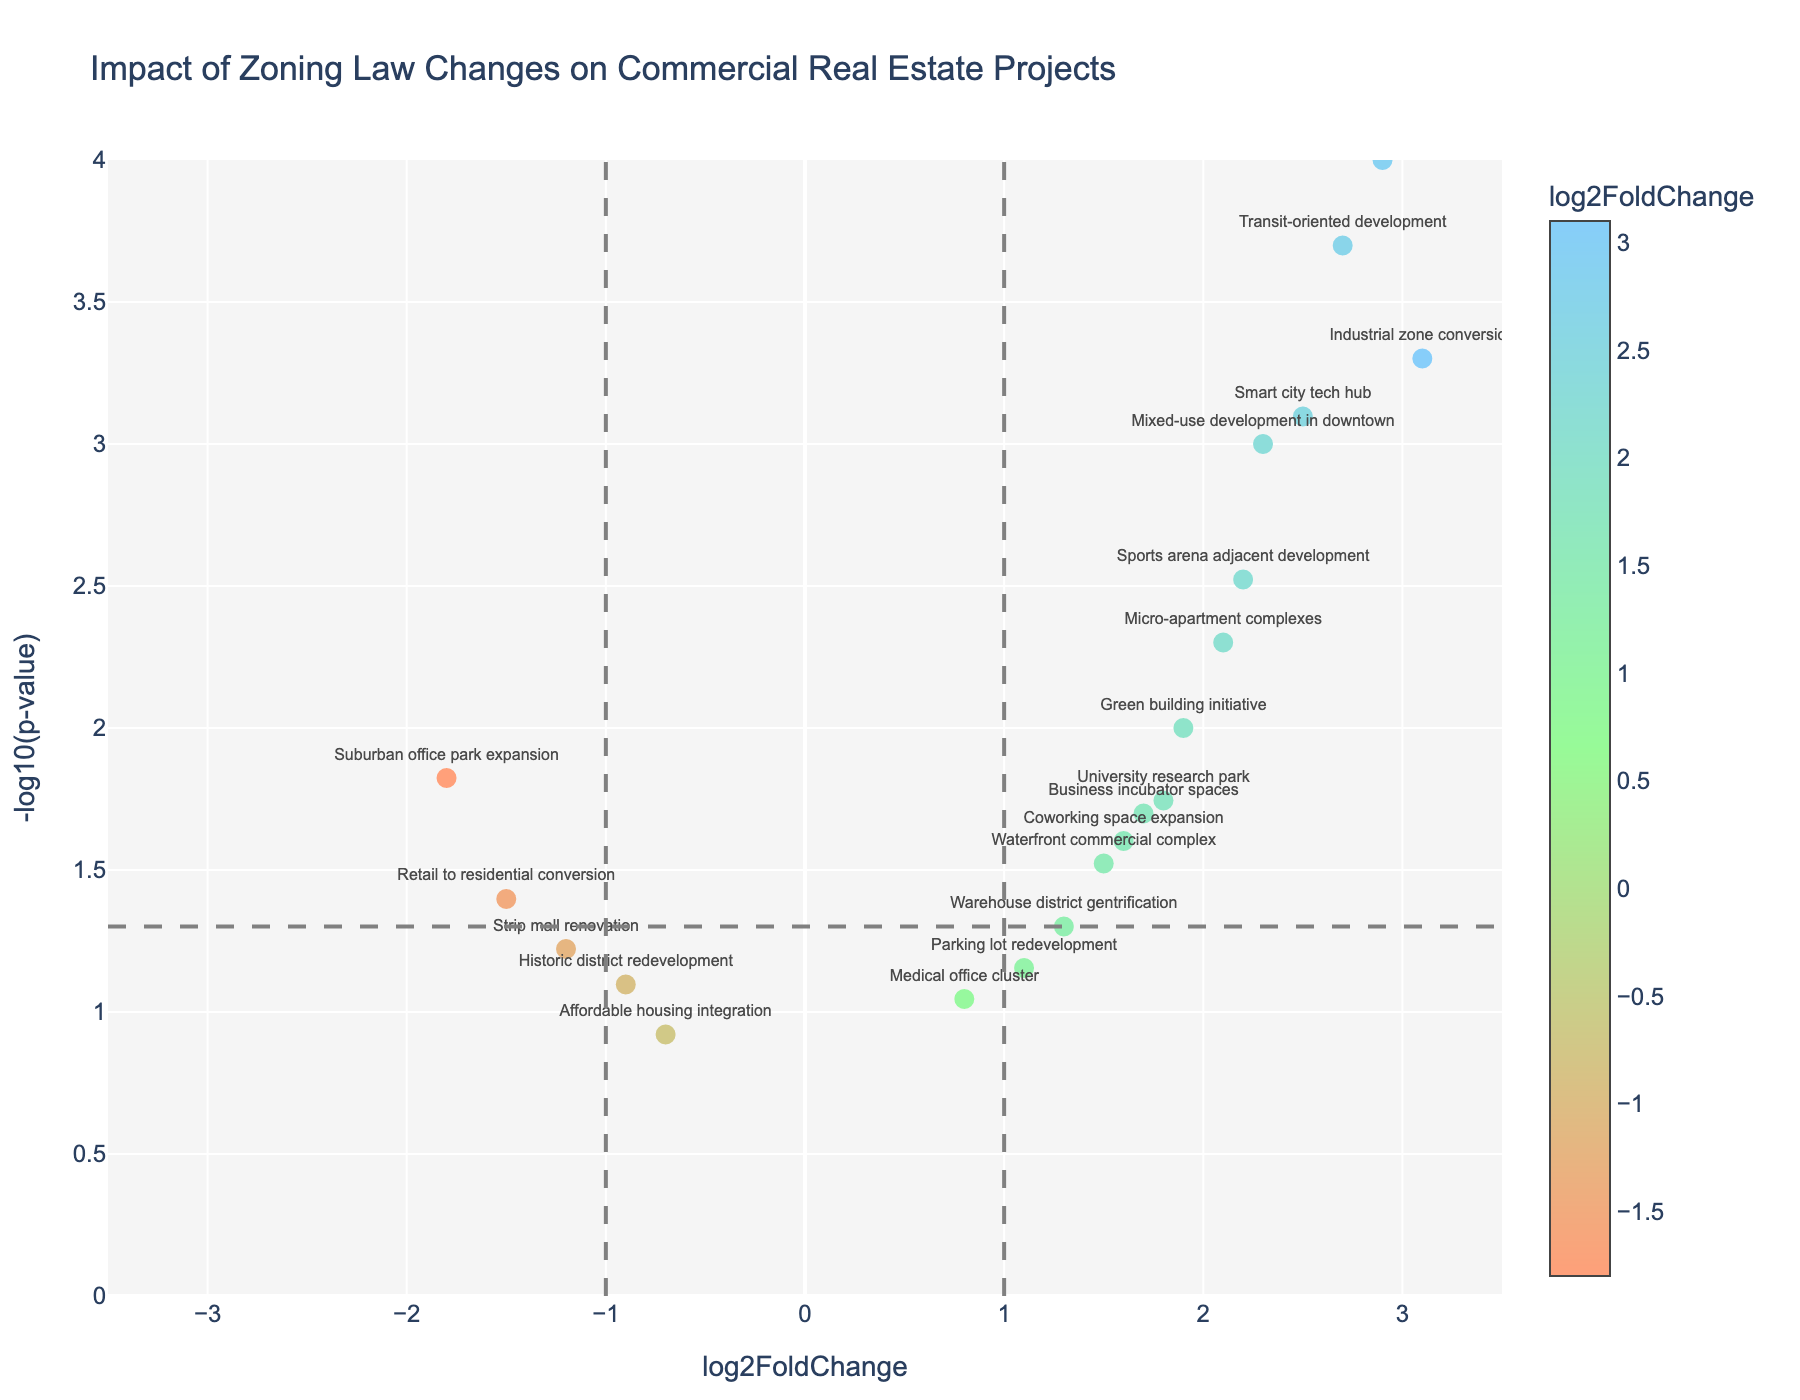what is the title of the figure? The title is displayed at the top of the plot and states the main topic or subject of the data being visualized.
Answer: Impact of Zoning Law Changes on Commercial Real Estate Projects How many projects have a significant p-value (less than 0.05) in the plot? Significant points are below -log10(0.05), located above the dashed horizontal line. Count all such points.
Answer: 14 Which project has the highest log2FoldChange value? The highest log2FoldChange value corresponds to the highest point on the x-axis. Identify the highest point and its associated project label.
Answer: Industrial zone conversion What is the log2FoldChange value of the Medical office cluster? Find the Medical office cluster in the plot and read its log2FoldChange value from the x-axis.
Answer: 0.8 Which two projects have negative log2FoldChange values but significant p-values? Identify projects with log2FoldChange < 0 and above the dashed horizontal line (significant p-values).
Answer: Suburban office park expansion and Retail to residential conversion How does the p-value of the Transit-oriented development project compare to that of the Business incubator spaces project? Look at the y-axis values (-log10(pValue)) for both projects and compare them. Higher values indicate lower p-values.
Answer: Transit-oriented development has a lower p-value Which project is closer to the log2FoldChange value of 1? Find log2FoldChange value 1 on the x-axis and identify the project closest to this value.
Answer: Parking lot redevelopment What is the range of log2FoldChange values represented in this plot? Find the minimum and maximum log2FoldChange values visually on the x-axis.
Answer: -1.8 to 3.1 Which project among 'Smart city tech hub' and 'Micro-apartment complexes' has a higher -log10(pValue)? Compare the y-axis values (-log10(pValue)) of both projects to see which one is higher.
Answer: Smart city tech hub 